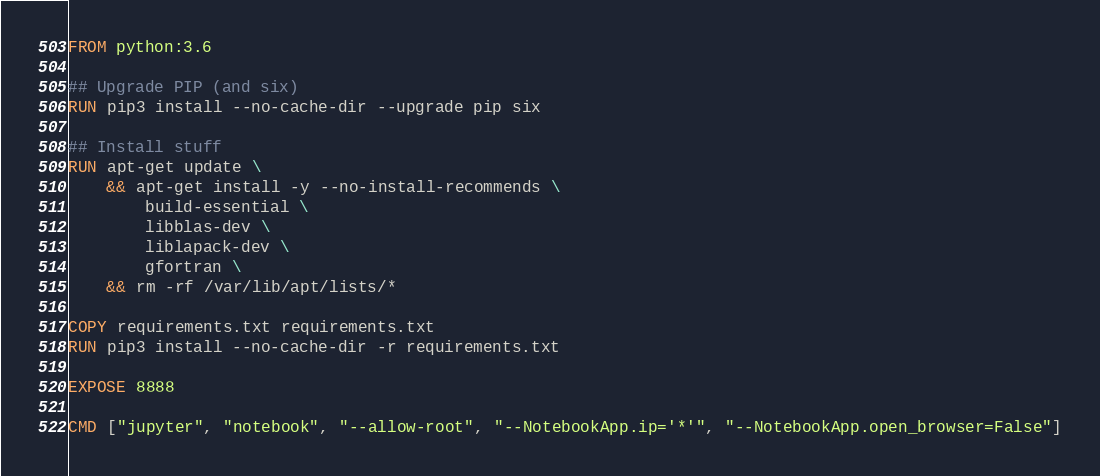Convert code to text. <code><loc_0><loc_0><loc_500><loc_500><_Dockerfile_>FROM python:3.6

## Upgrade PIP (and six)
RUN pip3 install --no-cache-dir --upgrade pip six

## Install stuff
RUN apt-get update \
    && apt-get install -y --no-install-recommends \
        build-essential \
        libblas-dev \
        liblapack-dev \
        gfortran \
    && rm -rf /var/lib/apt/lists/*

COPY requirements.txt requirements.txt
RUN pip3 install --no-cache-dir -r requirements.txt

EXPOSE 8888

CMD ["jupyter", "notebook", "--allow-root", "--NotebookApp.ip='*'", "--NotebookApp.open_browser=False"]</code> 